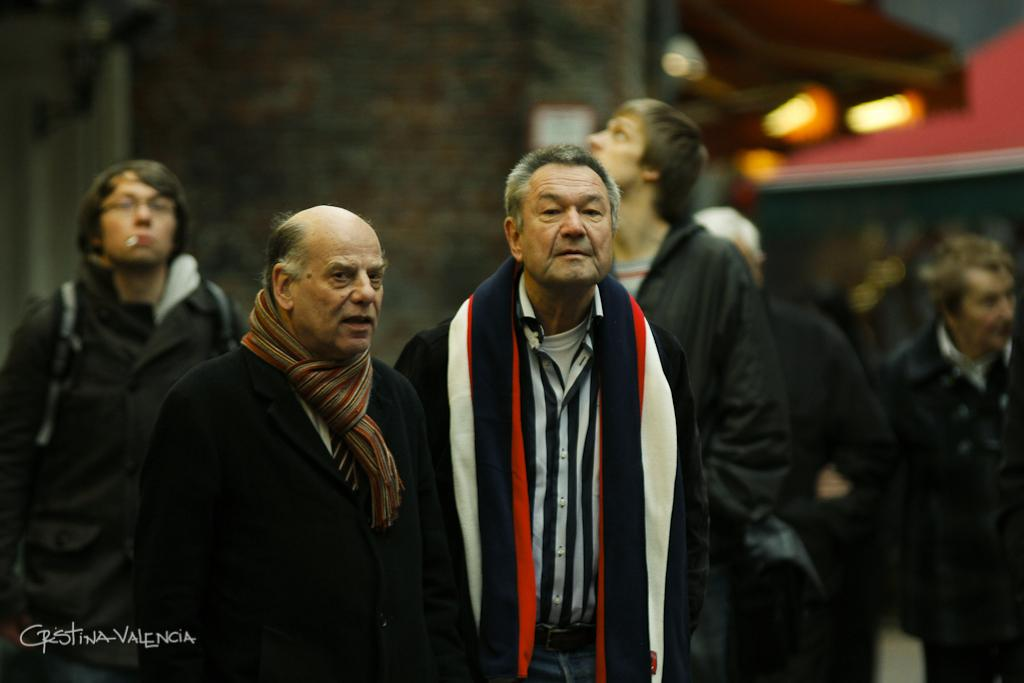How many people are in the image? There is a group of people in the image, but the exact number cannot be determined from the provided facts. What can be seen in the background of the image? There are lights and objects visible in the background of the image. Where is the text located in the image? The text is in the bottom left corner of the image. What type of honey is being collected by the people in the image? There is no mention of honey or any activity related to collecting honey in the image. 